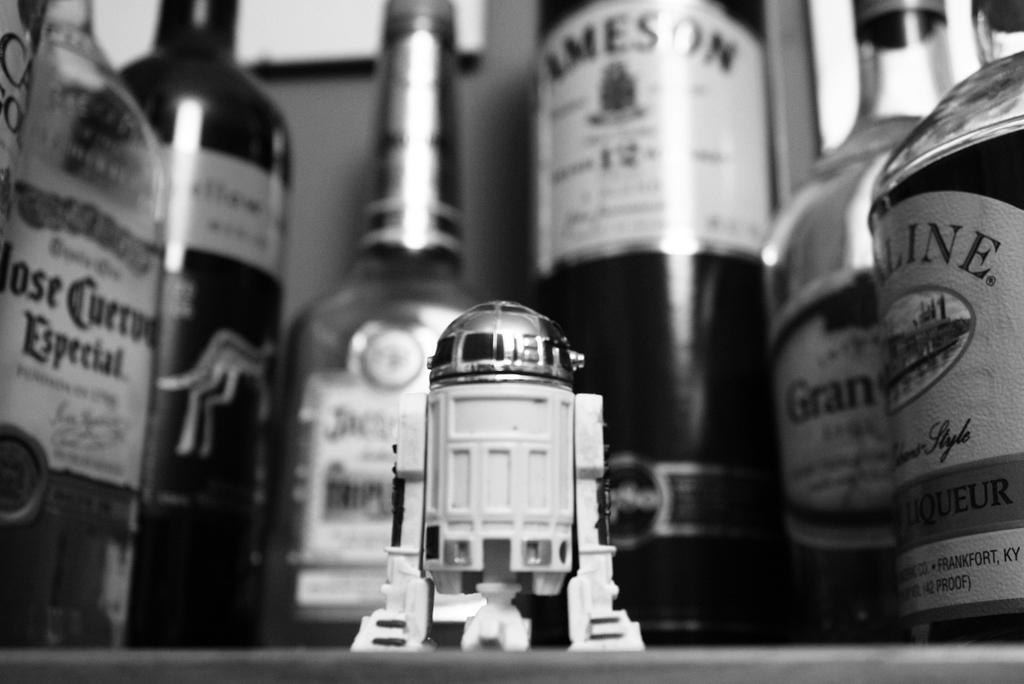What can be seen in the image related to beverages? There are bottles with different labels in the image. What object is located in the middle of the image? There is a toy in the middle of the image. How many hats are on the shelf in the image? There is no shelf or hat present in the image. 